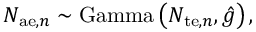Convert formula to latex. <formula><loc_0><loc_0><loc_500><loc_500>N _ { a e , n } \sim G a m m a \left ( N _ { t e , n } , \hat { g } \right ) ,</formula> 